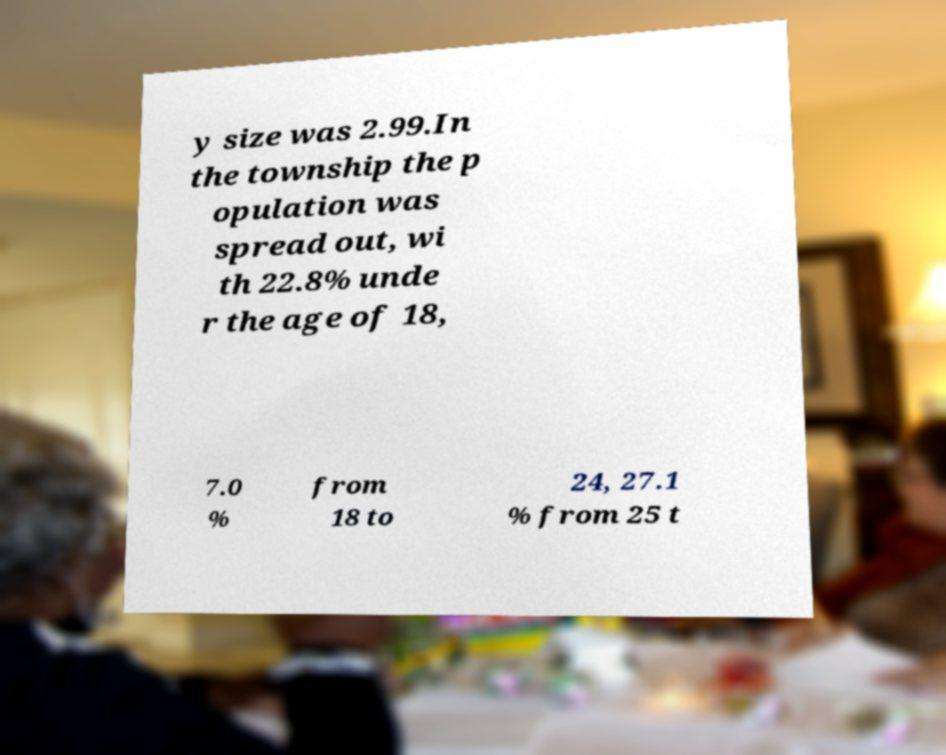I need the written content from this picture converted into text. Can you do that? y size was 2.99.In the township the p opulation was spread out, wi th 22.8% unde r the age of 18, 7.0 % from 18 to 24, 27.1 % from 25 t 